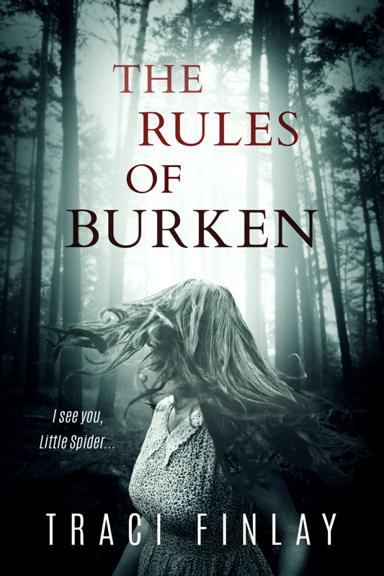Can you describe the mood set by the cover of 'The Rules of Burken'? The cover of 'The Rules of Burken' sets a chilling, mysterious mood. The image shows a shadowy figure in a dense, foggy forest, invoking a sense of isolation and foreboding, typical elements that aim to intrigue and unsettle the reader. How does this mood impact the potential reader's expectations? This haunting atmosphere likely heightens readers' expectations for a suspenseful, possibly psychological thriller. It can make potential readers anticipate a gripping, edge-of-your-seat narrative that delves into dark, mysterious plots or character dynamics. 